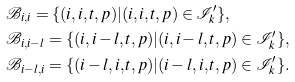<formula> <loc_0><loc_0><loc_500><loc_500>& \mathcal { B } _ { i , i } = \{ ( i , i , t , p ) | ( i , i , t , p ) \in \mathcal { I } ^ { \prime } _ { k } \} , \\ & \mathcal { B } _ { i , i - l } = \{ ( i , i - l , t , p ) | ( i , i - l , t , p ) \in \mathcal { I } ^ { \prime } _ { k } \} , \\ & \mathcal { B } _ { i - l , i } = \{ ( i - l , i , t , p ) | ( i - l , i , t , p ) \in \mathcal { I } ^ { \prime } _ { k } \} .</formula> 